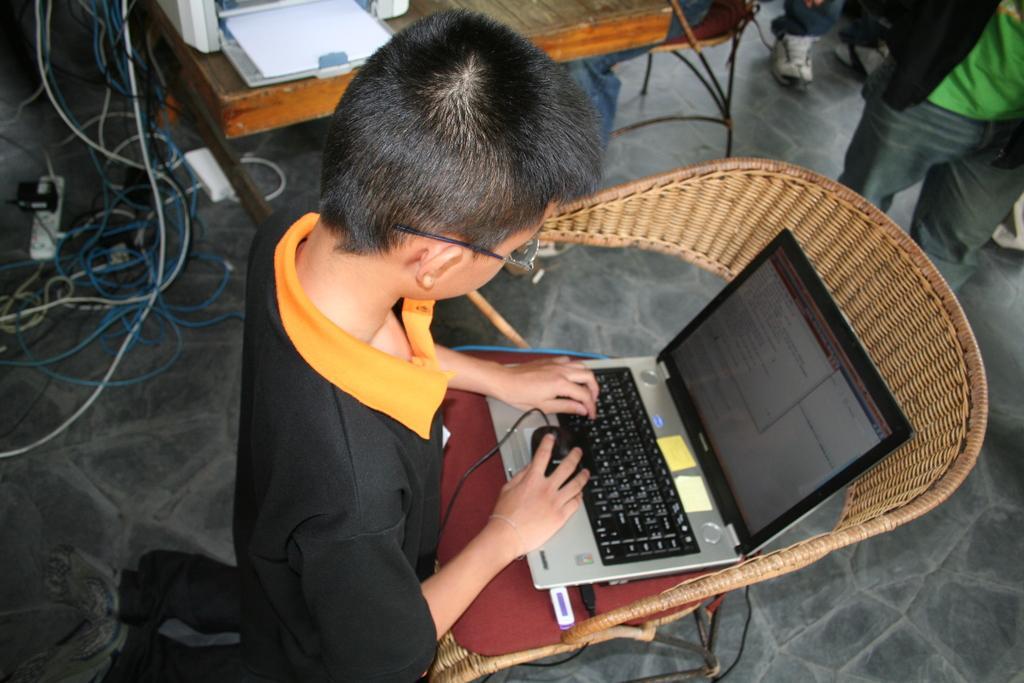Please provide a concise description of this image. In this image I can see a person kneeling on a surface holding a mouse. In front of the person there is a laptop which is on a chair and a pen drive is connected to it. On the right side they are a person standing and to the top of the image I can see a table beside to it there are some wire, a switchboard and an adaptor. 